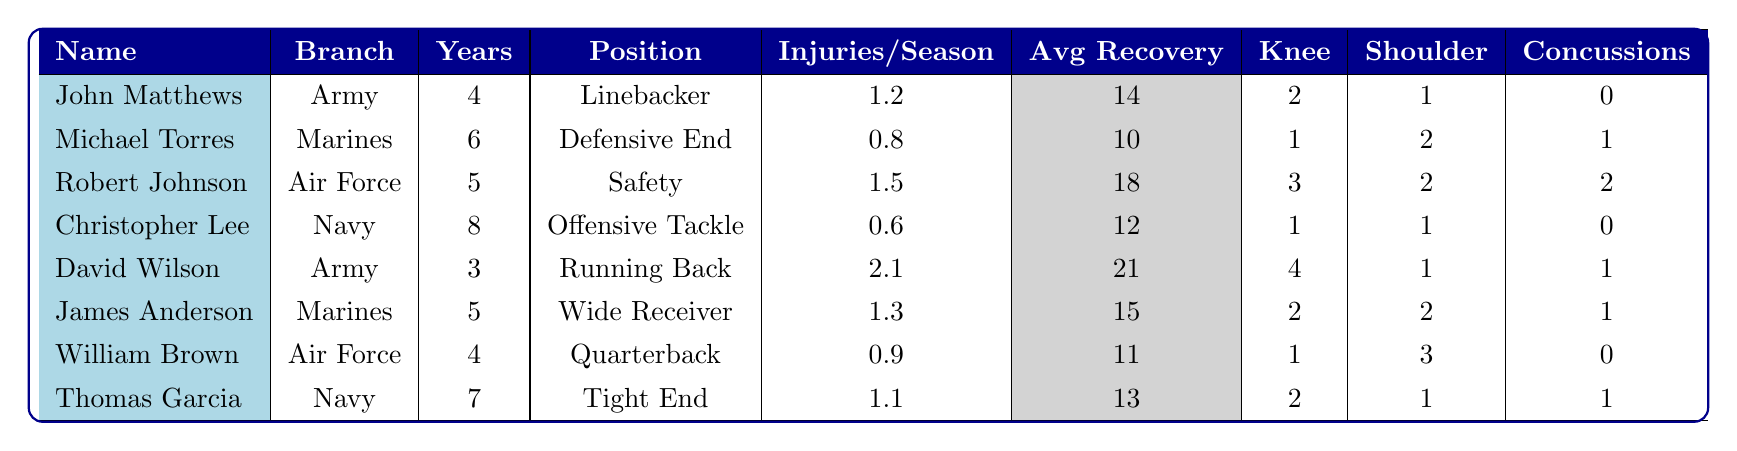What is the average number of injuries per season for players in the Army? There are two Army players: John Matthews (1.2) and David Wilson (2.1). The average is calculated as (1.2 + 2.1) / 2 = 1.65.
Answer: 1.65 Which player has the highest average recovery days? Robert Johnson has the highest average recovery days at 18.
Answer: 18 How many players had concussions? By counting the players with non-zero concussion values: Michael Torres (1), Robert Johnson (2), David Wilson (1), James Anderson (1), and Thomas Garcia (1), there are 5 players with concussions.
Answer: 5 What is the total number of shoulder injuries among all players? The shoulder injuries are 1 (Matthews) + 2 (Torres) + 2 (Johnson) + 1 (Lee) + 1 (Wilson) + 2 (Anderson) + 3 (Brown) + 1 (Garcia) = 13.
Answer: 13 Which branch has the player with the most knee injuries? David Wilson from the Army has the most knee injuries (4).
Answer: Army What is the average injuries per season for players with military experience? The total injuries per season are 1.2 + 0.8 + 1.5 + 0.6 + 2.1 + 1.3 + 0.9 + 1.1 = 9.5, and there are 8 players, so the average is 9.5 / 8 = 1.1875.
Answer: 1.19 Among the players, who sustained the fewest injuries per season and what is the number? Christopher Lee from the Navy has the fewest injuries per season at 0.6.
Answer: 0.6 Is there a player who has not sustained any concussions? Yes, John Matthews and Christopher Lee have not sustained any concussions (0 each).
Answer: Yes Calculate the difference in average recovery days between the player with the highest and lowest. Robert Johnson has 18 days, and Christopher Lee has 12 days; the difference is 18 - 12 = 6.
Answer: 6 How many players served in the Marines? There are two players who served in the Marines: Michael Torres and James Anderson.
Answer: 2 Which military branch had the most prevalent knee injuries? The Army had the highest total knee injuries with 6 (2 from Matthews and 4 from Wilson).
Answer: Army 